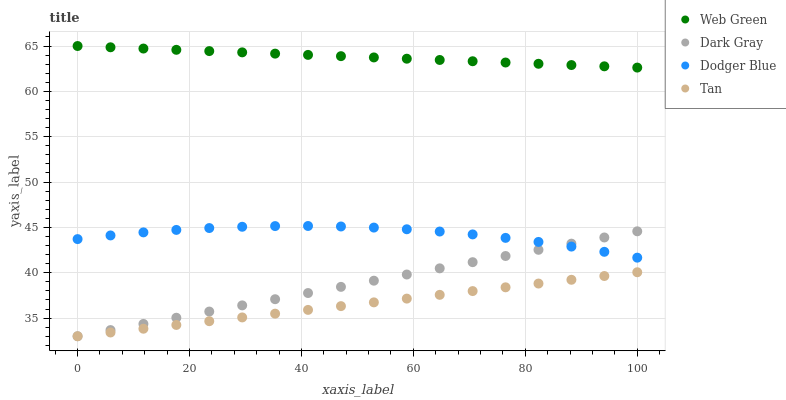Does Tan have the minimum area under the curve?
Answer yes or no. Yes. Does Web Green have the maximum area under the curve?
Answer yes or no. Yes. Does Dodger Blue have the minimum area under the curve?
Answer yes or no. No. Does Dodger Blue have the maximum area under the curve?
Answer yes or no. No. Is Tan the smoothest?
Answer yes or no. Yes. Is Dodger Blue the roughest?
Answer yes or no. Yes. Is Dodger Blue the smoothest?
Answer yes or no. No. Is Tan the roughest?
Answer yes or no. No. Does Dark Gray have the lowest value?
Answer yes or no. Yes. Does Dodger Blue have the lowest value?
Answer yes or no. No. Does Web Green have the highest value?
Answer yes or no. Yes. Does Dodger Blue have the highest value?
Answer yes or no. No. Is Tan less than Dodger Blue?
Answer yes or no. Yes. Is Web Green greater than Tan?
Answer yes or no. Yes. Does Dark Gray intersect Tan?
Answer yes or no. Yes. Is Dark Gray less than Tan?
Answer yes or no. No. Is Dark Gray greater than Tan?
Answer yes or no. No. Does Tan intersect Dodger Blue?
Answer yes or no. No. 